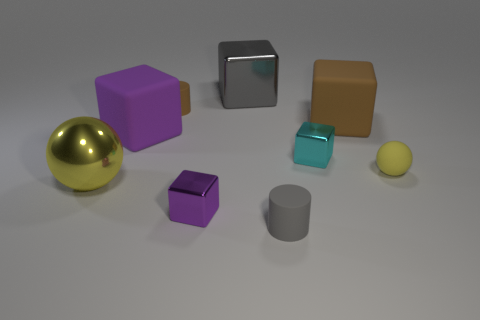Subtract all small cyan metallic cubes. How many cubes are left? 4 Subtract all gray cubes. How many cubes are left? 4 Subtract all blocks. How many objects are left? 4 Subtract all cyan blocks. Subtract all blue cylinders. How many blocks are left? 4 Add 3 large things. How many large things exist? 7 Subtract 0 yellow cubes. How many objects are left? 9 Subtract all large blocks. Subtract all purple things. How many objects are left? 4 Add 2 brown rubber objects. How many brown rubber objects are left? 4 